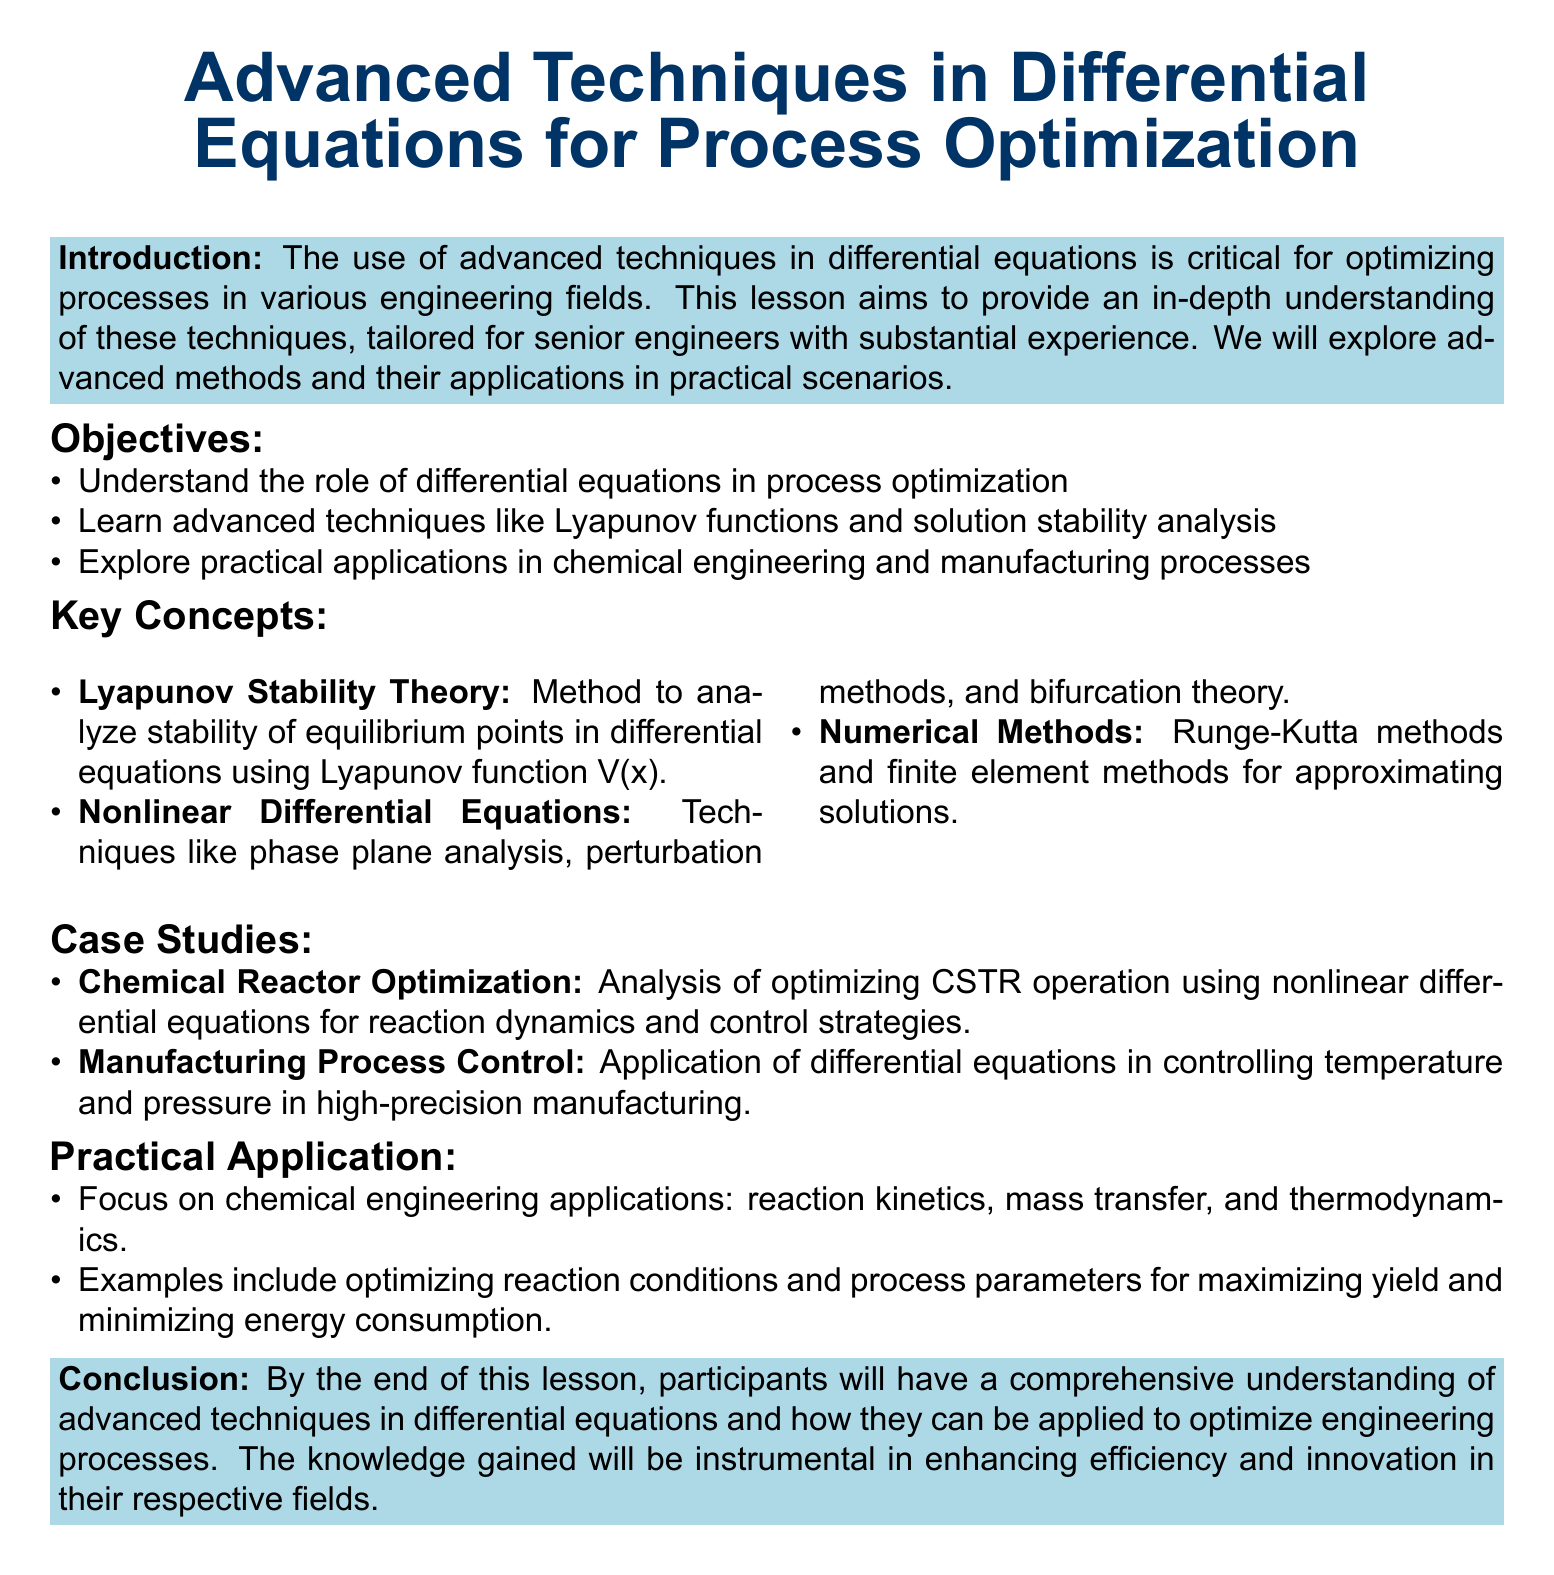What are the objectives of the lesson? The objectives are listed under the Objectives section of the document, specifically outlining what participants will learn.
Answer: Understand the role of differential equations in process optimization, Learn advanced techniques like Lyapunov functions and solution stability analysis, Explore practical applications in chemical engineering and manufacturing processes What method is used to analyze stability in Lyapunov Stability Theory? The document states that the method involves using a Lyapunov function V(x) to analyze stability of equilibrium points.
Answer: Lyapunov function V(x) What is a practical application mentioned in the lesson? The document outlines examples of practical applications, specifically mentioning one related to chemical engineering.
Answer: Optimizing reaction conditions and process parameters Which numerical method is mentioned in the Key Concepts section? The Key Concepts section includes a bullet point referring to numerical methods.
Answer: Runge-Kutta methods What case study focuses on optimizing CSTR operation? The document lists a case study under the Case Studies section that specifically deals with this topic.
Answer: Chemical Reactor Optimization What is the main focus of the practical applications section? The section provides a specific area of focus within the practical applications described in the lesson.
Answer: Chemical engineering applications What theory aids in handling nonlinear differential equations? The document mentions a specific theory in relation to nonlinear differential equations in the Key Concepts section.
Answer: Bifurcation theory How many case studies are provided in the lesson? There is a specific number of case studies mentioned in the document under the Case Studies section.
Answer: Two 